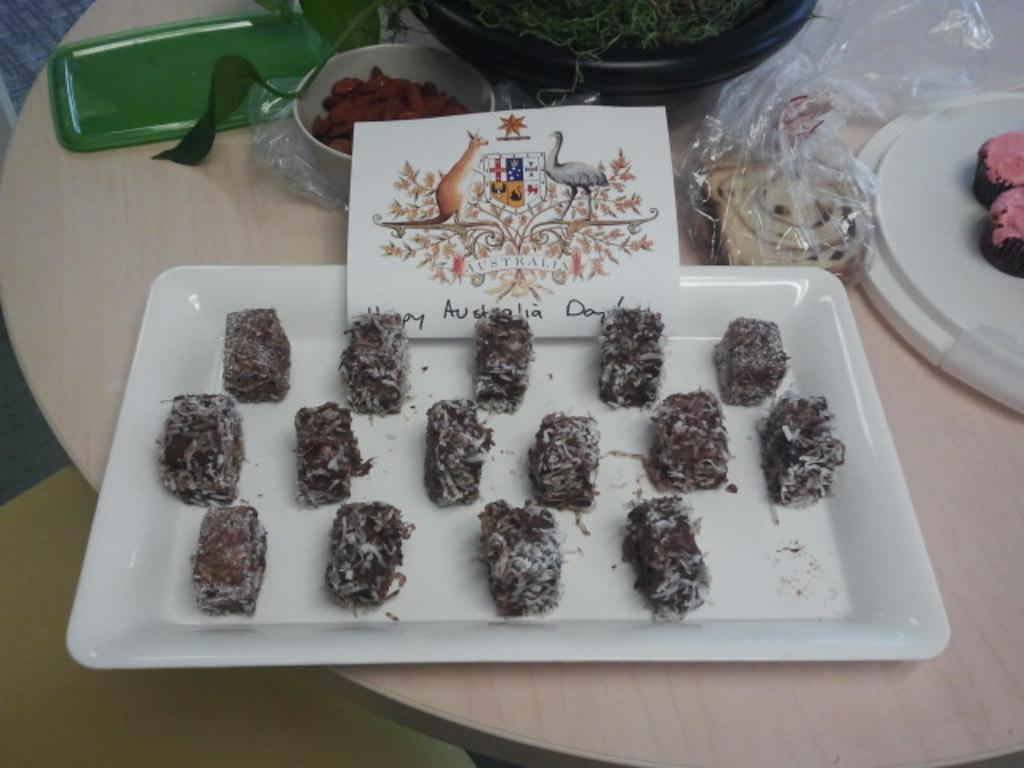What is on the wooden table in the image? There is a plate, a bowl, a card, a plastic cover, and food on the wooden table. What type of food is on the wooden table? There are objects on the wooden table, but the specific type of food is not mentioned in the facts. What else is present on the wooden table besides the mentioned items? There are objects on the wooden table, but the specific objects are not mentioned in the facts. Where is the nearest market to the wooden table in the image? The facts provided do not mention any information about a market, so it is not possible to determine the location of the nearest market. What type of net is visible on the wooden table in the image? There is no net visible on the wooden table in the image. 